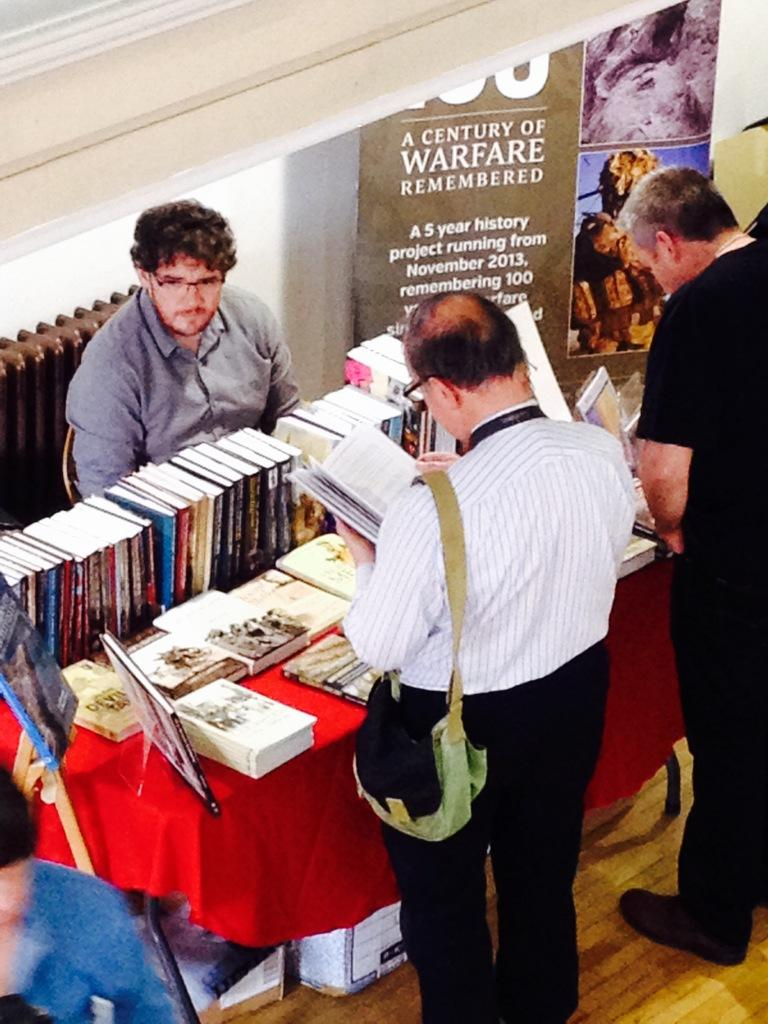Provide a one-sentence caption for the provided image. A man sitting at a table of books next to a sign reading "A Century of Warfare Remembered". 